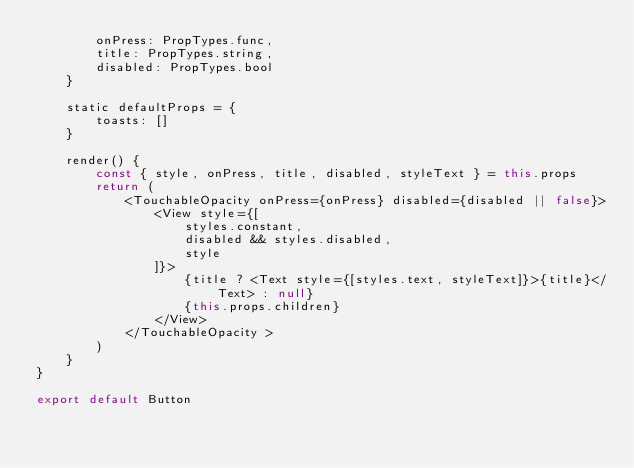Convert code to text. <code><loc_0><loc_0><loc_500><loc_500><_JavaScript_>        onPress: PropTypes.func,
        title: PropTypes.string,
        disabled: PropTypes.bool
    }

    static defaultProps = {
        toasts: []
    }

    render() {
        const { style, onPress, title, disabled, styleText } = this.props
        return (
            <TouchableOpacity onPress={onPress} disabled={disabled || false}>
                <View style={[
                    styles.constant,
                    disabled && styles.disabled,
                    style
                ]}>
                    {title ? <Text style={[styles.text, styleText]}>{title}</Text> : null}
                    {this.props.children}
                </View>
            </TouchableOpacity >
        )
    }
}

export default Button
</code> 